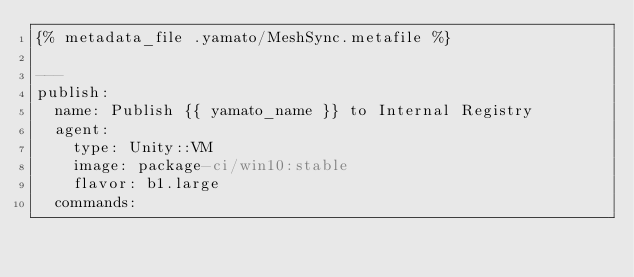<code> <loc_0><loc_0><loc_500><loc_500><_YAML_>{% metadata_file .yamato/MeshSync.metafile %}
   
---
publish:
  name: Publish {{ yamato_name }} to Internal Registry
  agent:
    type: Unity::VM
    image: package-ci/win10:stable
    flavor: b1.large
  commands:</code> 